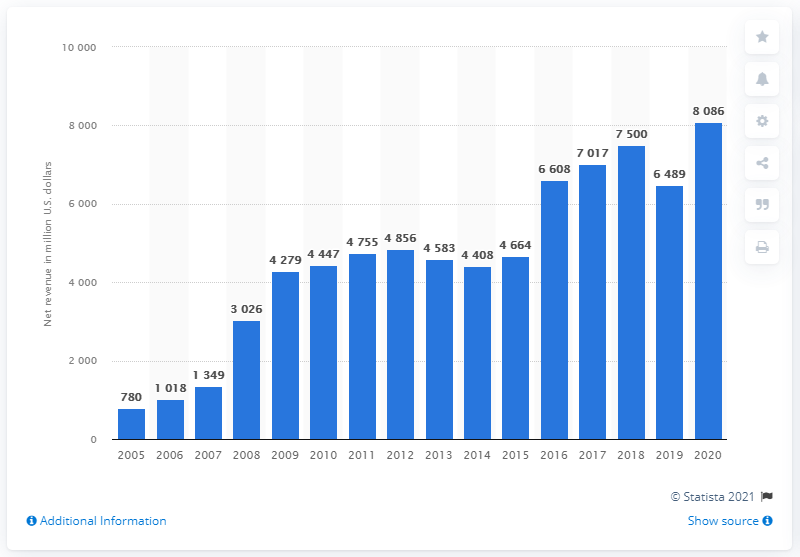Mention a couple of crucial points in this snapshot. In the year 2018, Activision secured a position in a ranking of leading global companies. Call of Duty has sold a significant number of copies over the course of its long life. This can be represented as 8086 copies. Activision Blizzard's annual revenue in 2020 was approximately 8086. 